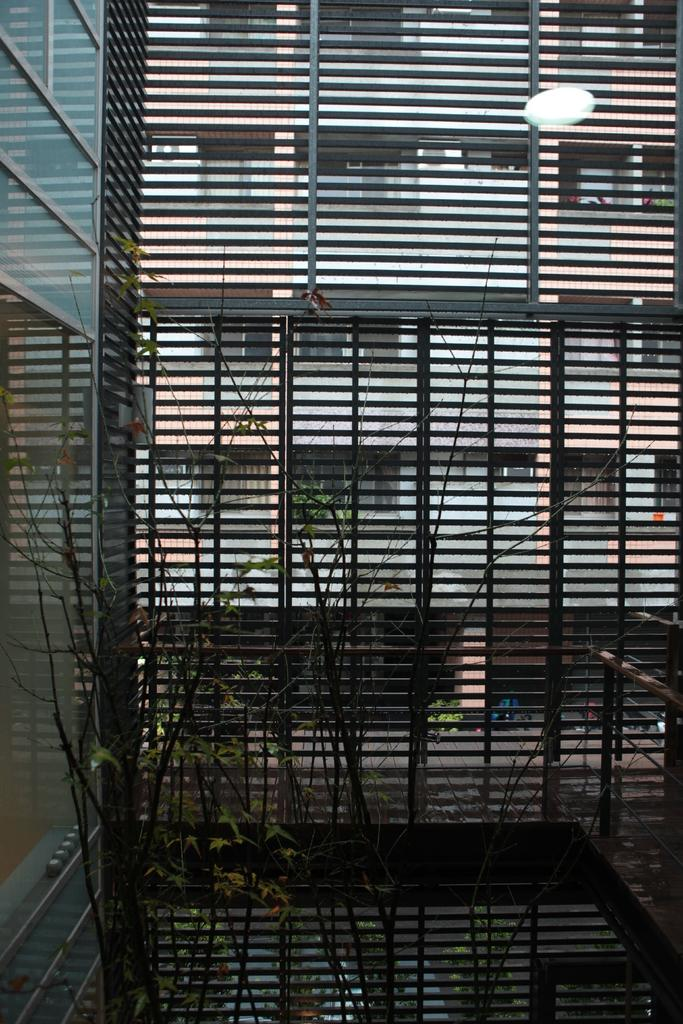What type of living organisms can be seen in the image? Plants can be seen in the image. What material are the bars visible in the image made of? The bars visible in the image are made of iron. What can be seen through the iron bars? A building is visible through the iron bars. What type of argument is taking place between the plants in the image? There is no argument taking place between the plants in the image, as plants do not engage in arguments. 